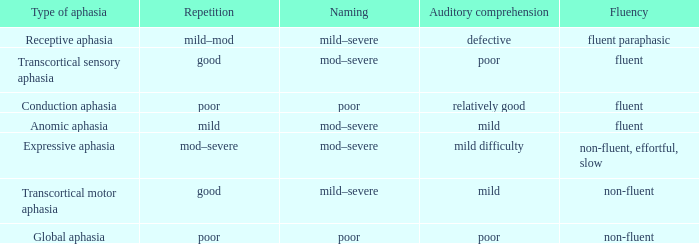Name the naming for fluent and poor comprehension Mod–severe. 